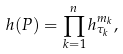Convert formula to latex. <formula><loc_0><loc_0><loc_500><loc_500>h ( P ) = \prod _ { k = 1 } ^ { n } h _ { \tau _ { k } } ^ { m _ { k } } ,</formula> 